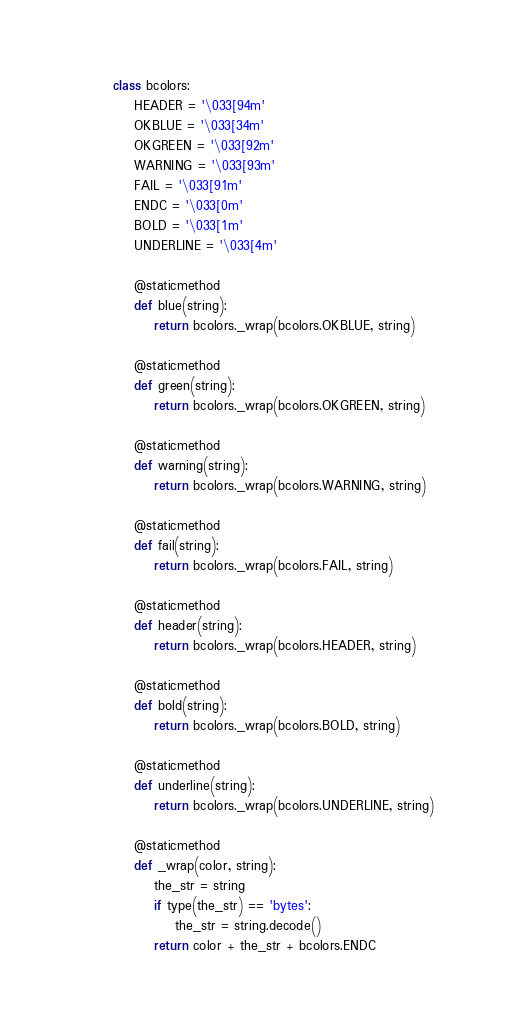<code> <loc_0><loc_0><loc_500><loc_500><_Python_>class bcolors:
    HEADER = '\033[94m'
    OKBLUE = '\033[34m'
    OKGREEN = '\033[92m'
    WARNING = '\033[93m'
    FAIL = '\033[91m'
    ENDC = '\033[0m'
    BOLD = '\033[1m'
    UNDERLINE = '\033[4m'

    @staticmethod
    def blue(string):
        return bcolors._wrap(bcolors.OKBLUE, string)

    @staticmethod
    def green(string):
        return bcolors._wrap(bcolors.OKGREEN, string)

    @staticmethod
    def warning(string):
        return bcolors._wrap(bcolors.WARNING, string)

    @staticmethod
    def fail(string):
        return bcolors._wrap(bcolors.FAIL, string)

    @staticmethod
    def header(string):
        return bcolors._wrap(bcolors.HEADER, string)

    @staticmethod
    def bold(string):
        return bcolors._wrap(bcolors.BOLD, string)

    @staticmethod
    def underline(string):
        return bcolors._wrap(bcolors.UNDERLINE, string)

    @staticmethod
    def _wrap(color, string):
        the_str = string
        if type(the_str) == 'bytes':
            the_str = string.decode()
        return color + the_str + bcolors.ENDC
</code> 